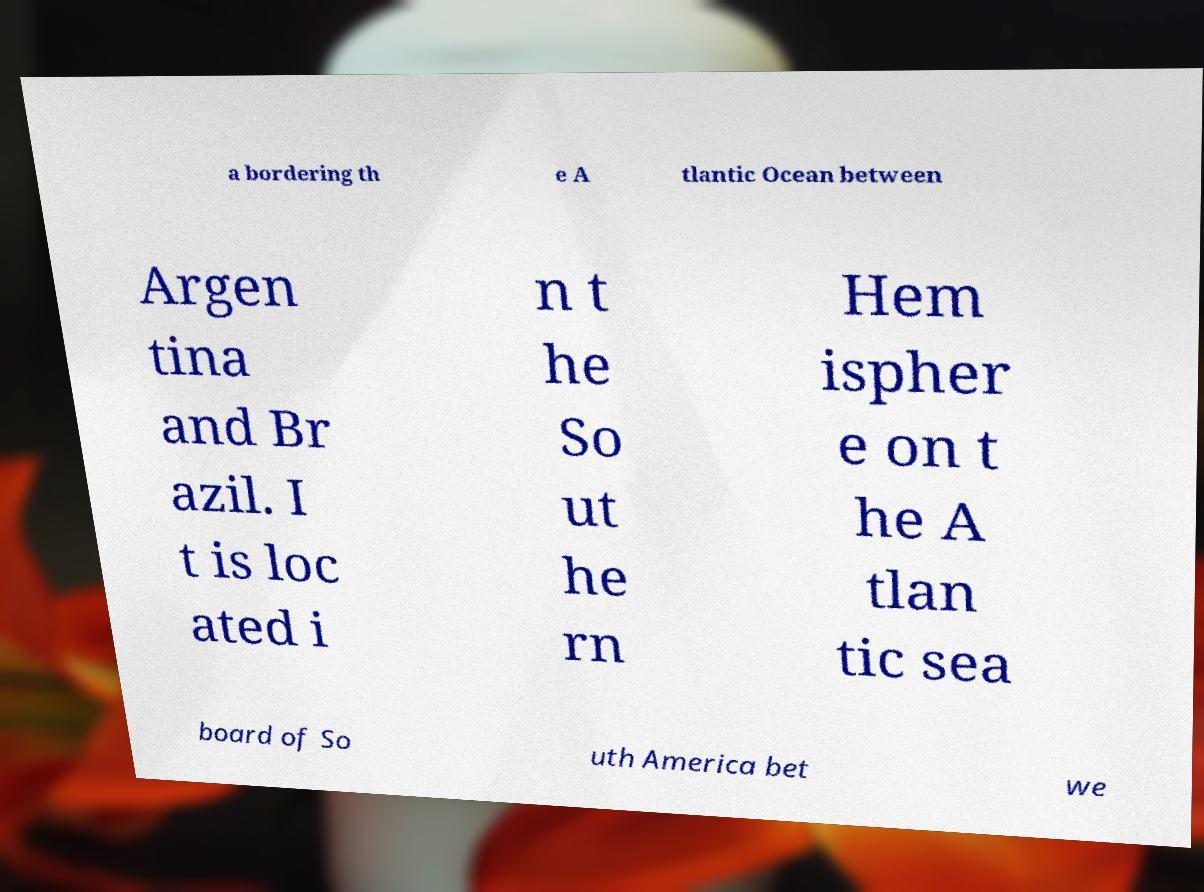There's text embedded in this image that I need extracted. Can you transcribe it verbatim? a bordering th e A tlantic Ocean between Argen tina and Br azil. I t is loc ated i n t he So ut he rn Hem ispher e on t he A tlan tic sea board of So uth America bet we 